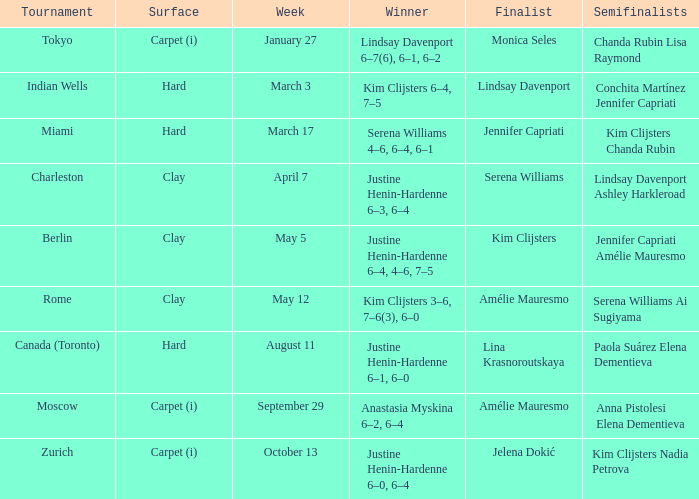Who was the winner against Lindsay Davenport? Kim Clijsters 6–4, 7–5. 